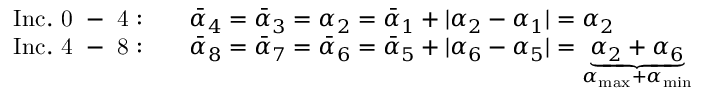Convert formula to latex. <formula><loc_0><loc_0><loc_500><loc_500>\begin{array} { r l } { I n c . 0 - 4 \colon \quad } & { \ B a r { \alpha } _ { 4 } = \ B a r { \alpha } _ { 3 } = \alpha _ { 2 } = \ B a r { \alpha } _ { 1 } + | \alpha _ { 2 } - \alpha _ { 1 } | = \alpha _ { 2 } } \\ { I n c . 4 - 8 \colon \quad } & { \ B a r { \alpha } _ { 8 } = \ B a r { \alpha } _ { 7 } = \ B a r { \alpha } _ { 6 } = \ B a r { \alpha } _ { 5 } + | \alpha _ { 6 } - \alpha _ { 5 } | = \underbrace { \alpha _ { 2 } + \alpha _ { 6 } } _ { \alpha _ { \max } + \alpha _ { \min } } } \end{array}</formula> 